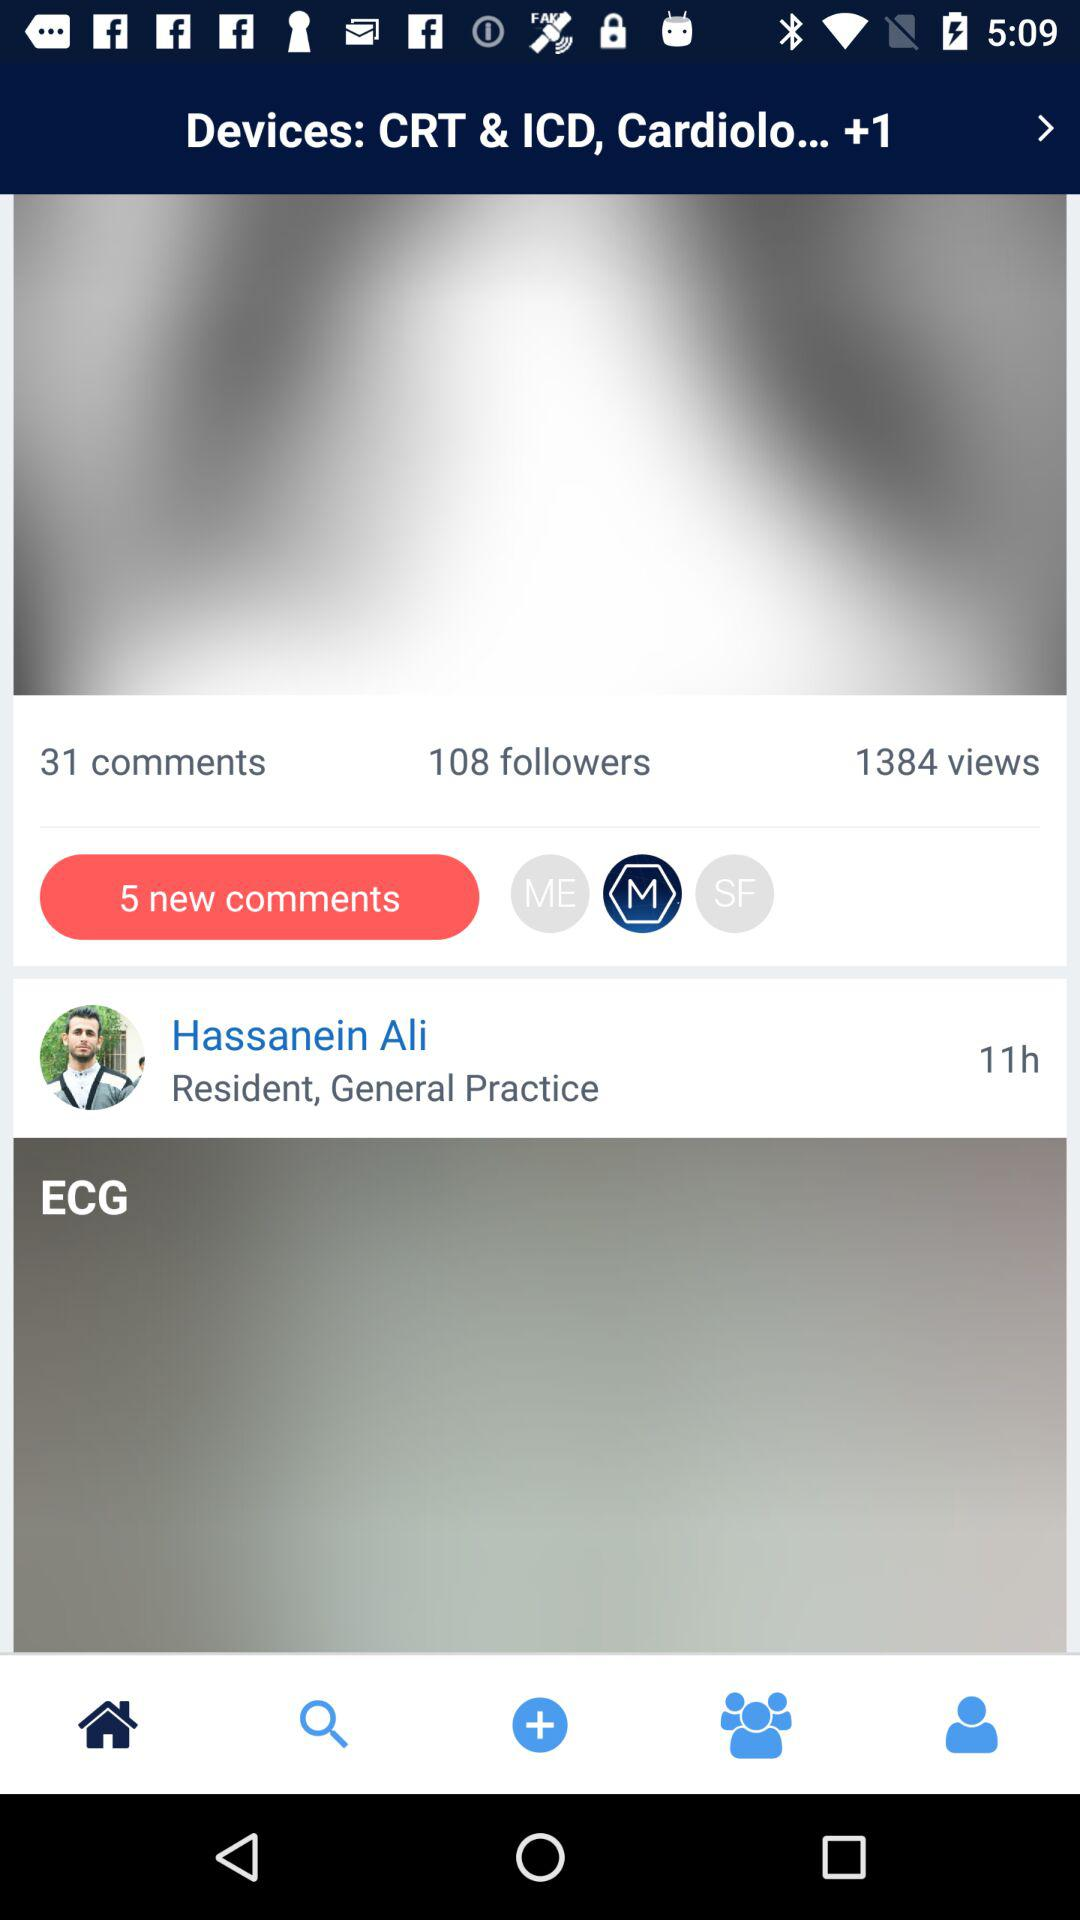How many new comments are there? There are 5 new comments. 